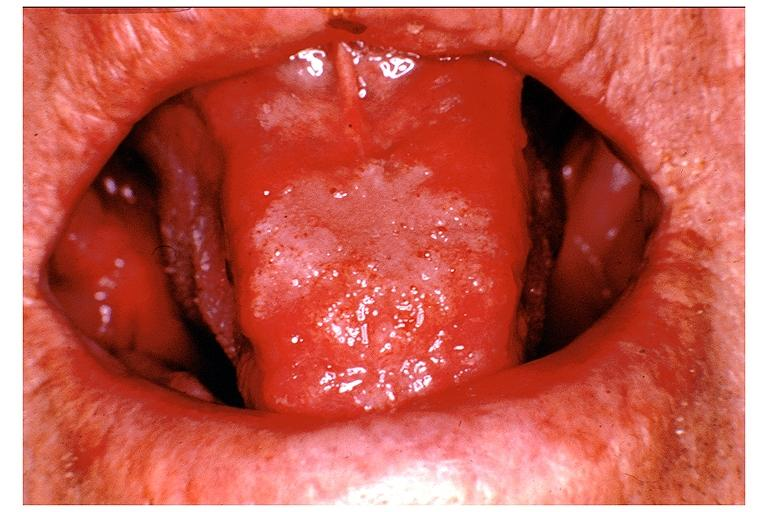s hemorrhage associated with placental abruption present?
Answer the question using a single word or phrase. No 